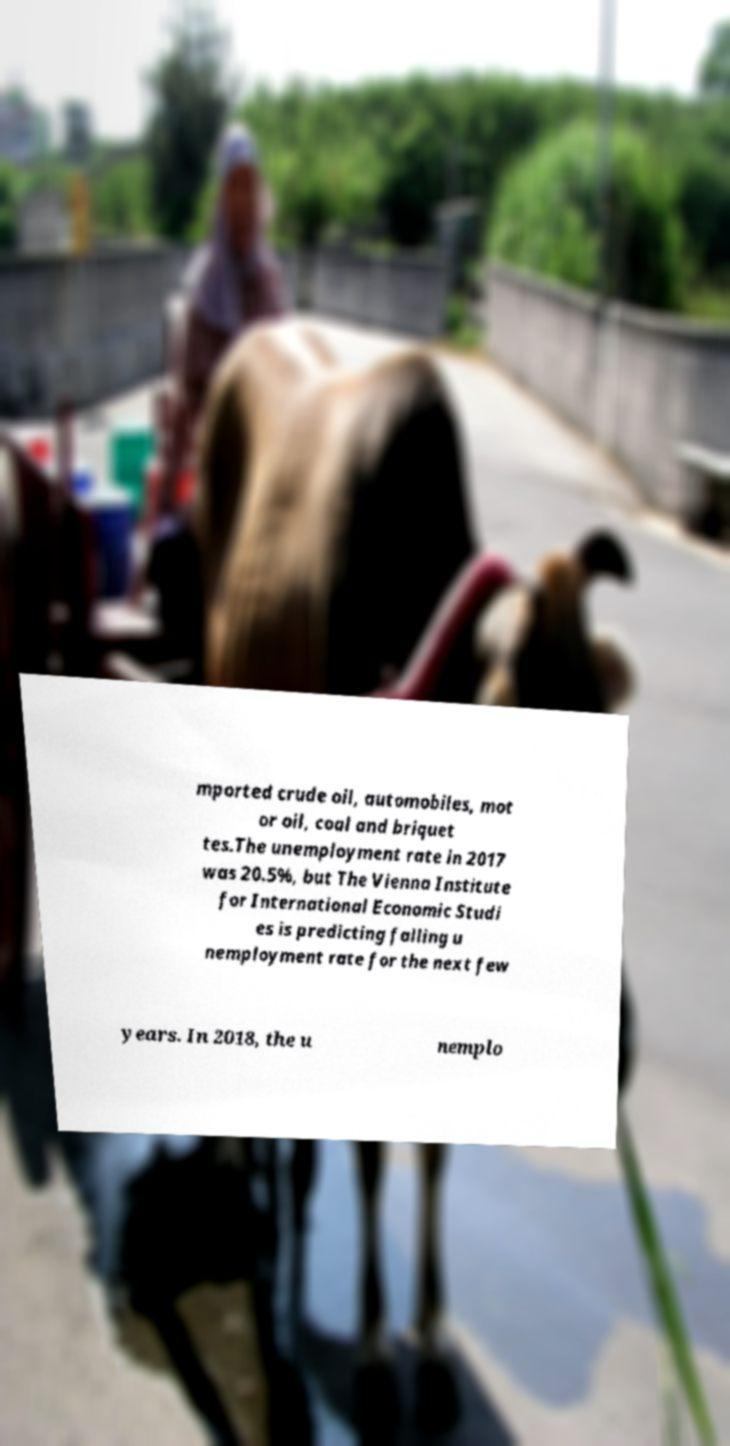Could you extract and type out the text from this image? mported crude oil, automobiles, mot or oil, coal and briquet tes.The unemployment rate in 2017 was 20.5%, but The Vienna Institute for International Economic Studi es is predicting falling u nemployment rate for the next few years. In 2018, the u nemplo 